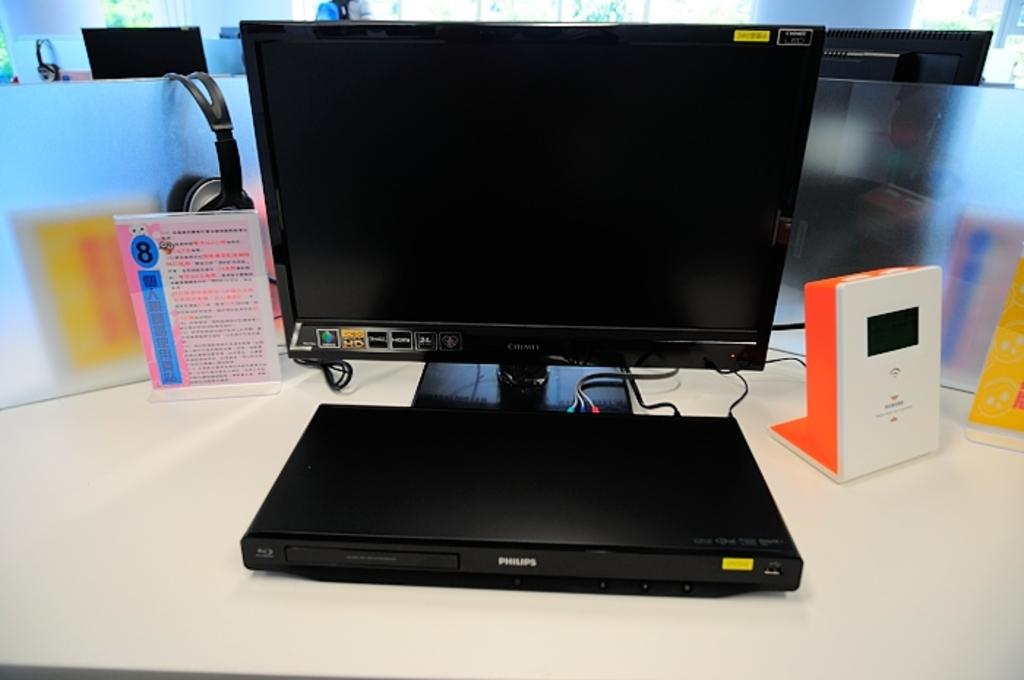<image>
Describe the image concisely. the word Philips is on the black machine 